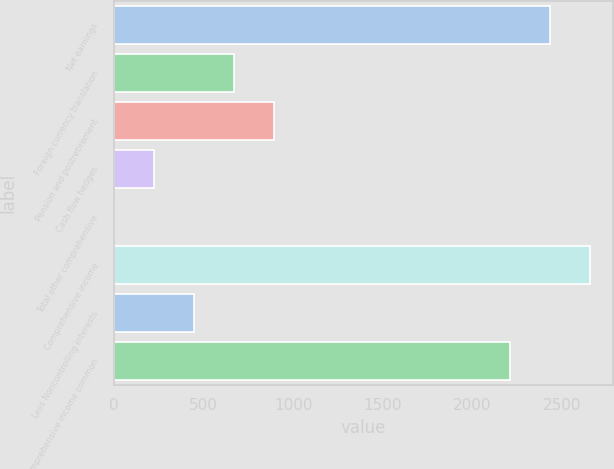Convert chart. <chart><loc_0><loc_0><loc_500><loc_500><bar_chart><fcel>Net earnings<fcel>Foreign currency translation<fcel>Pension and postretirement<fcel>Cash flow hedges<fcel>Total other comprehensive<fcel>Comprehensive income<fcel>Less Noncontrolling interests<fcel>Comprehensive income common<nl><fcel>2429.4<fcel>671.2<fcel>893.6<fcel>226.4<fcel>4<fcel>2651.8<fcel>448.8<fcel>2207<nl></chart> 